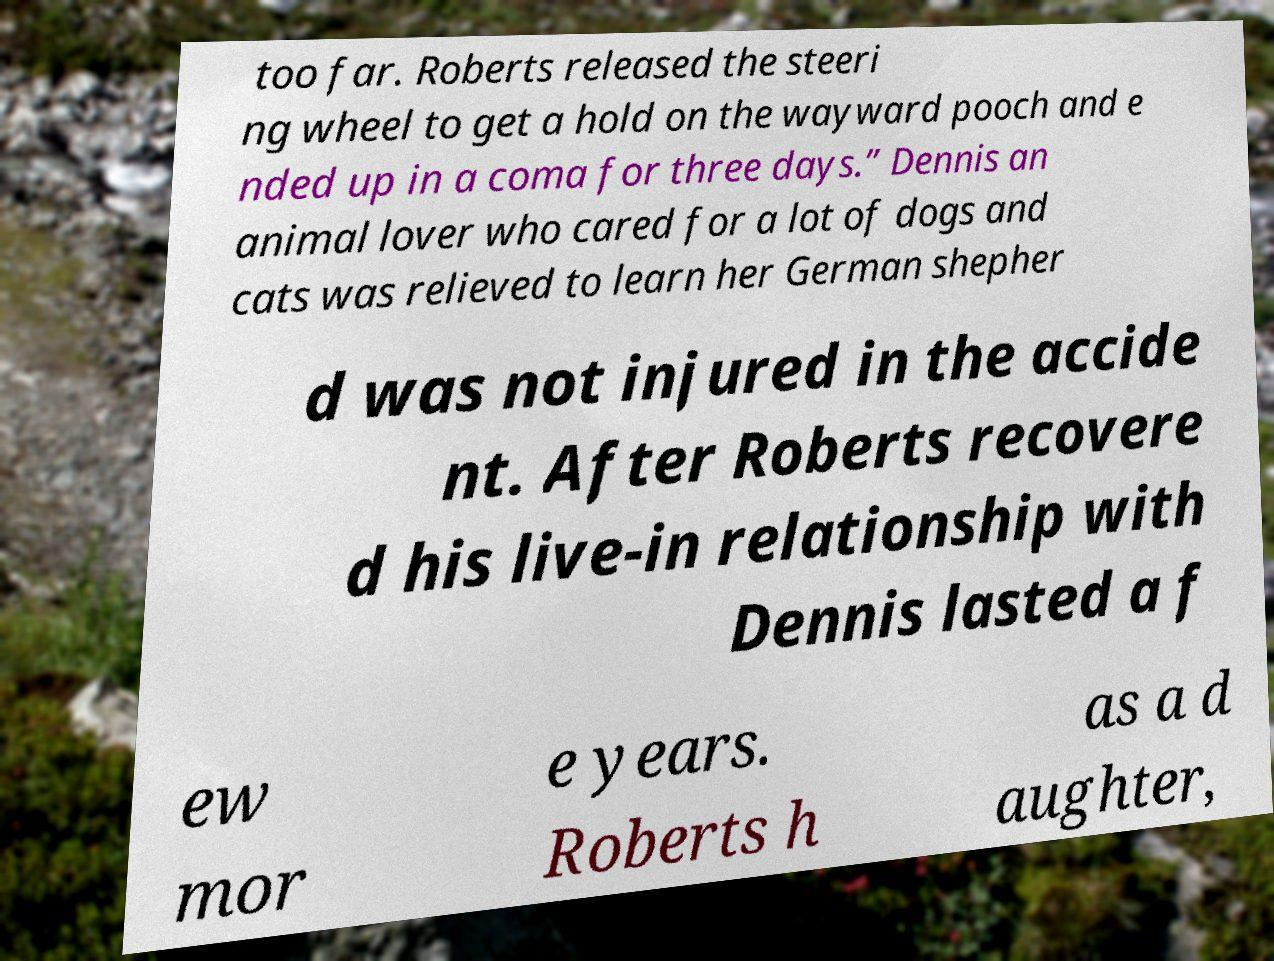I need the written content from this picture converted into text. Can you do that? too far. Roberts released the steeri ng wheel to get a hold on the wayward pooch and e nded up in a coma for three days.” Dennis an animal lover who cared for a lot of dogs and cats was relieved to learn her German shepher d was not injured in the accide nt. After Roberts recovere d his live-in relationship with Dennis lasted a f ew mor e years. Roberts h as a d aughter, 